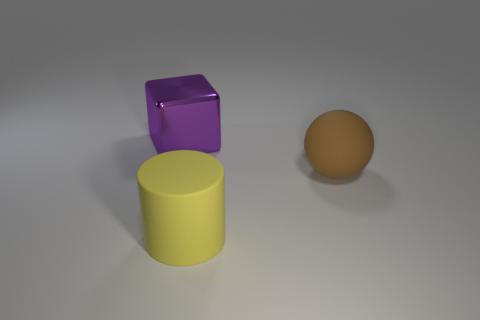Do the object that is behind the large brown sphere and the yellow object have the same shape?
Offer a very short reply. No. What color is the large object on the right side of the large rubber thing on the left side of the big brown sphere?
Your response must be concise. Brown. Are there fewer blocks than small blue matte cylinders?
Offer a very short reply. No. Is there a small brown thing that has the same material as the purple object?
Give a very brief answer. No. There is a yellow rubber thing; are there any brown rubber things behind it?
Your answer should be very brief. Yes. Are the big brown ball and the thing behind the big matte ball made of the same material?
Your answer should be compact. No. How many tiny purple matte balls are there?
Your response must be concise. 0. What size is the rubber thing that is left of the big brown matte ball?
Offer a very short reply. Large. What number of purple things have the same size as the sphere?
Your answer should be compact. 1. There is a thing that is right of the purple metal thing and on the left side of the big brown thing; what material is it?
Offer a very short reply. Rubber. 